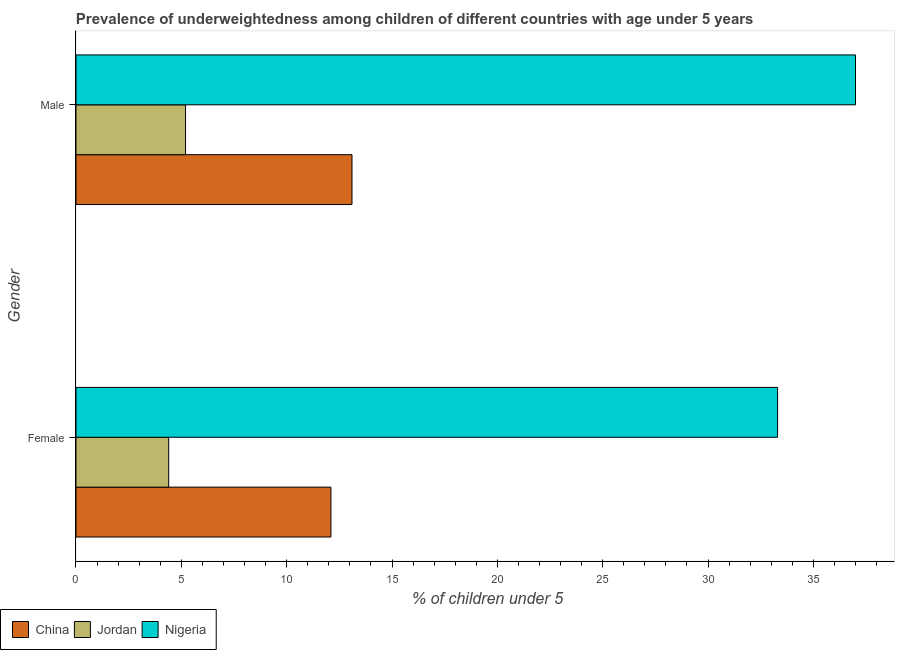Are the number of bars per tick equal to the number of legend labels?
Provide a succinct answer. Yes. Are the number of bars on each tick of the Y-axis equal?
Offer a terse response. Yes. What is the label of the 1st group of bars from the top?
Your answer should be compact. Male. What is the percentage of underweighted male children in China?
Make the answer very short. 13.1. Across all countries, what is the maximum percentage of underweighted male children?
Keep it short and to the point. 37. Across all countries, what is the minimum percentage of underweighted female children?
Give a very brief answer. 4.4. In which country was the percentage of underweighted female children maximum?
Your answer should be compact. Nigeria. In which country was the percentage of underweighted male children minimum?
Your answer should be compact. Jordan. What is the total percentage of underweighted female children in the graph?
Provide a short and direct response. 49.8. What is the difference between the percentage of underweighted male children in Nigeria and that in Jordan?
Give a very brief answer. 31.8. What is the difference between the percentage of underweighted male children in Nigeria and the percentage of underweighted female children in China?
Give a very brief answer. 24.9. What is the average percentage of underweighted female children per country?
Ensure brevity in your answer.  16.6. What is the difference between the percentage of underweighted female children and percentage of underweighted male children in Jordan?
Provide a succinct answer. -0.8. What is the ratio of the percentage of underweighted male children in Jordan to that in China?
Provide a succinct answer. 0.4. Is the percentage of underweighted male children in China less than that in Jordan?
Keep it short and to the point. No. What does the 1st bar from the top in Female represents?
Make the answer very short. Nigeria. What does the 2nd bar from the bottom in Male represents?
Your answer should be compact. Jordan. Are all the bars in the graph horizontal?
Ensure brevity in your answer.  Yes. What is the difference between two consecutive major ticks on the X-axis?
Offer a very short reply. 5. Are the values on the major ticks of X-axis written in scientific E-notation?
Give a very brief answer. No. Does the graph contain any zero values?
Keep it short and to the point. No. What is the title of the graph?
Your answer should be very brief. Prevalence of underweightedness among children of different countries with age under 5 years. Does "St. Lucia" appear as one of the legend labels in the graph?
Give a very brief answer. No. What is the label or title of the X-axis?
Your answer should be very brief.  % of children under 5. What is the label or title of the Y-axis?
Give a very brief answer. Gender. What is the  % of children under 5 of China in Female?
Provide a short and direct response. 12.1. What is the  % of children under 5 of Jordan in Female?
Give a very brief answer. 4.4. What is the  % of children under 5 in Nigeria in Female?
Offer a very short reply. 33.3. What is the  % of children under 5 in China in Male?
Give a very brief answer. 13.1. What is the  % of children under 5 in Jordan in Male?
Provide a short and direct response. 5.2. Across all Gender, what is the maximum  % of children under 5 of China?
Make the answer very short. 13.1. Across all Gender, what is the maximum  % of children under 5 in Jordan?
Provide a succinct answer. 5.2. Across all Gender, what is the minimum  % of children under 5 in China?
Offer a terse response. 12.1. Across all Gender, what is the minimum  % of children under 5 of Jordan?
Make the answer very short. 4.4. Across all Gender, what is the minimum  % of children under 5 of Nigeria?
Your answer should be very brief. 33.3. What is the total  % of children under 5 in China in the graph?
Give a very brief answer. 25.2. What is the total  % of children under 5 in Jordan in the graph?
Make the answer very short. 9.6. What is the total  % of children under 5 in Nigeria in the graph?
Keep it short and to the point. 70.3. What is the difference between the  % of children under 5 in China in Female and that in Male?
Your answer should be very brief. -1. What is the difference between the  % of children under 5 in China in Female and the  % of children under 5 in Jordan in Male?
Provide a succinct answer. 6.9. What is the difference between the  % of children under 5 in China in Female and the  % of children under 5 in Nigeria in Male?
Offer a terse response. -24.9. What is the difference between the  % of children under 5 in Jordan in Female and the  % of children under 5 in Nigeria in Male?
Offer a terse response. -32.6. What is the average  % of children under 5 in Jordan per Gender?
Keep it short and to the point. 4.8. What is the average  % of children under 5 of Nigeria per Gender?
Ensure brevity in your answer.  35.15. What is the difference between the  % of children under 5 of China and  % of children under 5 of Nigeria in Female?
Make the answer very short. -21.2. What is the difference between the  % of children under 5 in Jordan and  % of children under 5 in Nigeria in Female?
Give a very brief answer. -28.9. What is the difference between the  % of children under 5 in China and  % of children under 5 in Nigeria in Male?
Your answer should be compact. -23.9. What is the difference between the  % of children under 5 of Jordan and  % of children under 5 of Nigeria in Male?
Keep it short and to the point. -31.8. What is the ratio of the  % of children under 5 of China in Female to that in Male?
Make the answer very short. 0.92. What is the ratio of the  % of children under 5 of Jordan in Female to that in Male?
Your answer should be very brief. 0.85. What is the ratio of the  % of children under 5 of Nigeria in Female to that in Male?
Your response must be concise. 0.9. What is the difference between the highest and the lowest  % of children under 5 of China?
Ensure brevity in your answer.  1. What is the difference between the highest and the lowest  % of children under 5 of Jordan?
Your answer should be very brief. 0.8. What is the difference between the highest and the lowest  % of children under 5 of Nigeria?
Keep it short and to the point. 3.7. 